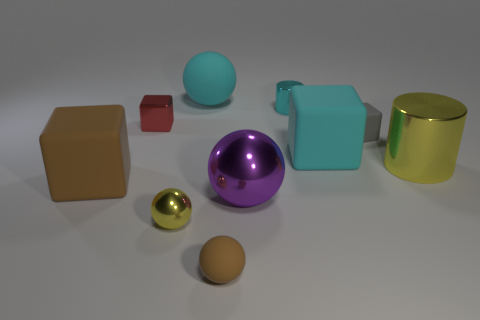What material is the small cube to the left of the small cyan metallic cylinder?
Your answer should be very brief. Metal. Are there more rubber things to the left of the purple metallic ball than objects?
Ensure brevity in your answer.  No. Are there any big rubber objects to the left of the tiny cube right of the big thing behind the small metallic block?
Keep it short and to the point. Yes. Are there any cubes on the left side of the purple object?
Offer a very short reply. Yes. How many rubber objects have the same color as the small metal sphere?
Your response must be concise. 0. The purple ball that is the same material as the tiny cyan cylinder is what size?
Offer a very short reply. Large. There is a yellow thing that is behind the big thing in front of the big block that is on the left side of the cyan matte cube; what is its size?
Offer a terse response. Large. What size is the yellow thing on the left side of the gray matte block?
Your answer should be very brief. Small. What number of red objects are tiny rubber balls or small metallic cylinders?
Keep it short and to the point. 0. Is there another object of the same size as the red object?
Offer a very short reply. Yes. 